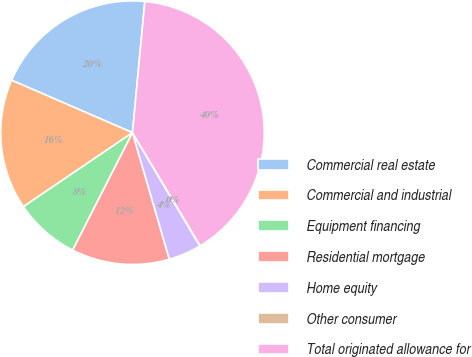<chart> <loc_0><loc_0><loc_500><loc_500><pie_chart><fcel>Commercial real estate<fcel>Commercial and industrial<fcel>Equipment financing<fcel>Residential mortgage<fcel>Home equity<fcel>Other consumer<fcel>Total originated allowance for<nl><fcel>19.98%<fcel>16.0%<fcel>8.02%<fcel>12.01%<fcel>4.03%<fcel>0.04%<fcel>39.93%<nl></chart> 